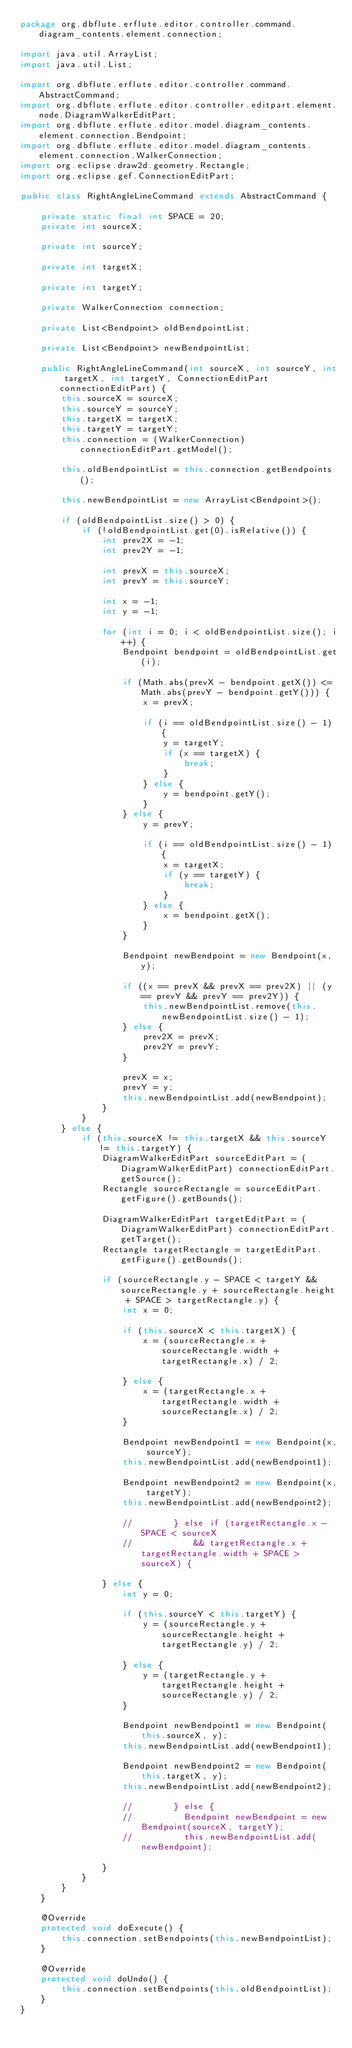<code> <loc_0><loc_0><loc_500><loc_500><_Java_>package org.dbflute.erflute.editor.controller.command.diagram_contents.element.connection;

import java.util.ArrayList;
import java.util.List;

import org.dbflute.erflute.editor.controller.command.AbstractCommand;
import org.dbflute.erflute.editor.controller.editpart.element.node.DiagramWalkerEditPart;
import org.dbflute.erflute.editor.model.diagram_contents.element.connection.Bendpoint;
import org.dbflute.erflute.editor.model.diagram_contents.element.connection.WalkerConnection;
import org.eclipse.draw2d.geometry.Rectangle;
import org.eclipse.gef.ConnectionEditPart;

public class RightAngleLineCommand extends AbstractCommand {

    private static final int SPACE = 20;
    private int sourceX;

    private int sourceY;

    private int targetX;

    private int targetY;

    private WalkerConnection connection;

    private List<Bendpoint> oldBendpointList;

    private List<Bendpoint> newBendpointList;

    public RightAngleLineCommand(int sourceX, int sourceY, int targetX, int targetY, ConnectionEditPart connectionEditPart) {
        this.sourceX = sourceX;
        this.sourceY = sourceY;
        this.targetX = targetX;
        this.targetY = targetY;
        this.connection = (WalkerConnection) connectionEditPart.getModel();

        this.oldBendpointList = this.connection.getBendpoints();

        this.newBendpointList = new ArrayList<Bendpoint>();

        if (oldBendpointList.size() > 0) {
            if (!oldBendpointList.get(0).isRelative()) {
                int prev2X = -1;
                int prev2Y = -1;

                int prevX = this.sourceX;
                int prevY = this.sourceY;

                int x = -1;
                int y = -1;

                for (int i = 0; i < oldBendpointList.size(); i++) {
                    Bendpoint bendpoint = oldBendpointList.get(i);

                    if (Math.abs(prevX - bendpoint.getX()) <= Math.abs(prevY - bendpoint.getY())) {
                        x = prevX;

                        if (i == oldBendpointList.size() - 1) {
                            y = targetY;
                            if (x == targetX) {
                                break;
                            }
                        } else {
                            y = bendpoint.getY();
                        }
                    } else {
                        y = prevY;

                        if (i == oldBendpointList.size() - 1) {
                            x = targetX;
                            if (y == targetY) {
                                break;
                            }
                        } else {
                            x = bendpoint.getX();
                        }
                    }

                    Bendpoint newBendpoint = new Bendpoint(x, y);

                    if ((x == prevX && prevX == prev2X) || (y == prevY && prevY == prev2Y)) {
                        this.newBendpointList.remove(this.newBendpointList.size() - 1);
                    } else {
                        prev2X = prevX;
                        prev2Y = prevY;
                    }

                    prevX = x;
                    prevY = y;
                    this.newBendpointList.add(newBendpoint);
                }
            }
        } else {
            if (this.sourceX != this.targetX && this.sourceY != this.targetY) {
                DiagramWalkerEditPart sourceEditPart = (DiagramWalkerEditPart) connectionEditPart.getSource();
                Rectangle sourceRectangle = sourceEditPart.getFigure().getBounds();

                DiagramWalkerEditPart targetEditPart = (DiagramWalkerEditPart) connectionEditPart.getTarget();
                Rectangle targetRectangle = targetEditPart.getFigure().getBounds();

                if (sourceRectangle.y - SPACE < targetY && sourceRectangle.y + sourceRectangle.height + SPACE > targetRectangle.y) {
                    int x = 0;

                    if (this.sourceX < this.targetX) {
                        x = (sourceRectangle.x + sourceRectangle.width + targetRectangle.x) / 2;

                    } else {
                        x = (targetRectangle.x + targetRectangle.width + sourceRectangle.x) / 2;
                    }

                    Bendpoint newBendpoint1 = new Bendpoint(x, sourceY);
                    this.newBendpointList.add(newBendpoint1);

                    Bendpoint newBendpoint2 = new Bendpoint(x, targetY);
                    this.newBendpointList.add(newBendpoint2);

                    //				} else if (targetRectangle.x - SPACE < sourceX
                    //						&& targetRectangle.x + targetRectangle.width + SPACE > sourceX) {

                } else {
                    int y = 0;

                    if (this.sourceY < this.targetY) {
                        y = (sourceRectangle.y + sourceRectangle.height + targetRectangle.y) / 2;

                    } else {
                        y = (targetRectangle.y + targetRectangle.height + sourceRectangle.y) / 2;
                    }

                    Bendpoint newBendpoint1 = new Bendpoint(this.sourceX, y);
                    this.newBendpointList.add(newBendpoint1);

                    Bendpoint newBendpoint2 = new Bendpoint(this.targetX, y);
                    this.newBendpointList.add(newBendpoint2);

                    //				} else {
                    //					Bendpoint newBendpoint = new Bendpoint(sourceX, targetY);
                    //					this.newBendpointList.add(newBendpoint);

                }
            }
        }
    }

    @Override
    protected void doExecute() {
        this.connection.setBendpoints(this.newBendpointList);
    }

    @Override
    protected void doUndo() {
        this.connection.setBendpoints(this.oldBendpointList);
    }
}
</code> 